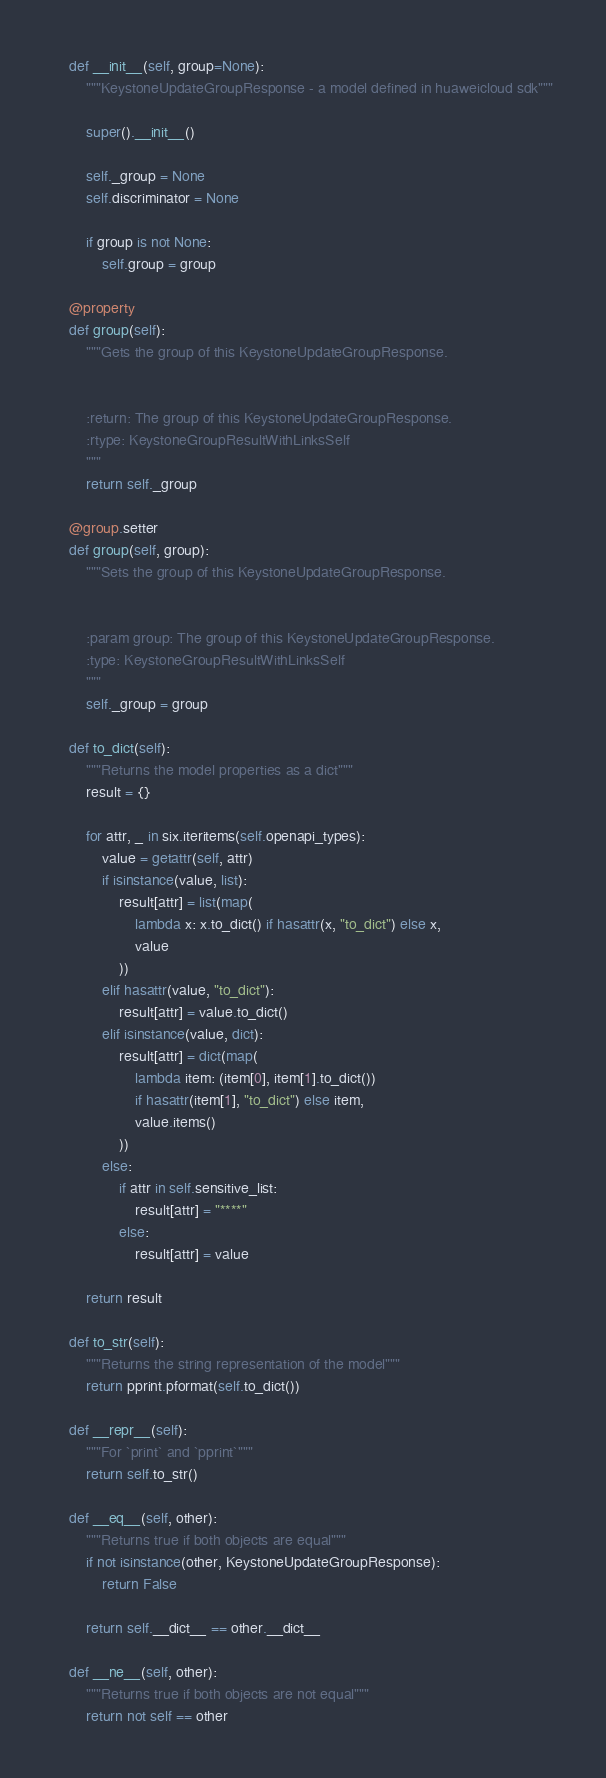<code> <loc_0><loc_0><loc_500><loc_500><_Python_>
    def __init__(self, group=None):
        """KeystoneUpdateGroupResponse - a model defined in huaweicloud sdk"""
        
        super().__init__()

        self._group = None
        self.discriminator = None

        if group is not None:
            self.group = group

    @property
    def group(self):
        """Gets the group of this KeystoneUpdateGroupResponse.


        :return: The group of this KeystoneUpdateGroupResponse.
        :rtype: KeystoneGroupResultWithLinksSelf
        """
        return self._group

    @group.setter
    def group(self, group):
        """Sets the group of this KeystoneUpdateGroupResponse.


        :param group: The group of this KeystoneUpdateGroupResponse.
        :type: KeystoneGroupResultWithLinksSelf
        """
        self._group = group

    def to_dict(self):
        """Returns the model properties as a dict"""
        result = {}

        for attr, _ in six.iteritems(self.openapi_types):
            value = getattr(self, attr)
            if isinstance(value, list):
                result[attr] = list(map(
                    lambda x: x.to_dict() if hasattr(x, "to_dict") else x,
                    value
                ))
            elif hasattr(value, "to_dict"):
                result[attr] = value.to_dict()
            elif isinstance(value, dict):
                result[attr] = dict(map(
                    lambda item: (item[0], item[1].to_dict())
                    if hasattr(item[1], "to_dict") else item,
                    value.items()
                ))
            else:
                if attr in self.sensitive_list:
                    result[attr] = "****"
                else:
                    result[attr] = value

        return result

    def to_str(self):
        """Returns the string representation of the model"""
        return pprint.pformat(self.to_dict())

    def __repr__(self):
        """For `print` and `pprint`"""
        return self.to_str()

    def __eq__(self, other):
        """Returns true if both objects are equal"""
        if not isinstance(other, KeystoneUpdateGroupResponse):
            return False

        return self.__dict__ == other.__dict__

    def __ne__(self, other):
        """Returns true if both objects are not equal"""
        return not self == other
</code> 